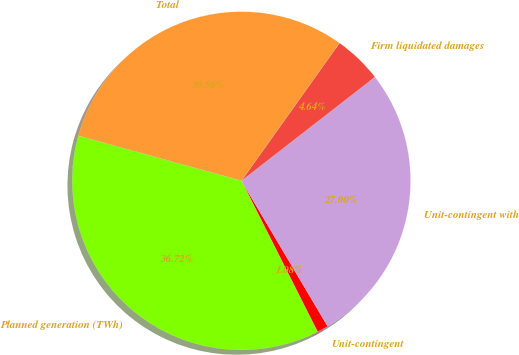<chart> <loc_0><loc_0><loc_500><loc_500><pie_chart><fcel>Unit-contingent<fcel>Unit-contingent with<fcel>Firm liquidated damages<fcel>Total<fcel>Planned generation (TWh)<nl><fcel>1.08%<fcel>27.0%<fcel>4.64%<fcel>30.56%<fcel>36.72%<nl></chart> 